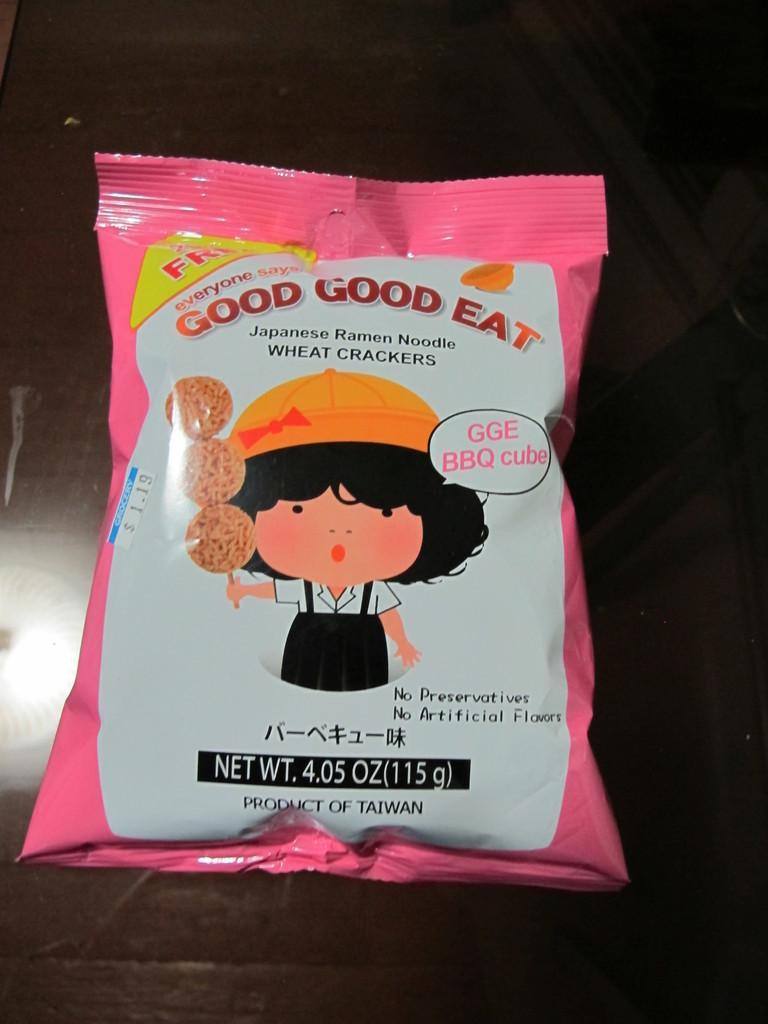What is present in the image that is packaged or wrapped? There is a packet in the image. Where is the packet located in the image? The packet is placed on a surface. What can be seen on the outside of the packet? There is an image, text, and a sticker on the packet. What type of coal is stored in the desk in the image? There is no desk or coal present in the image; it features a packet with an image, text, and sticker. 